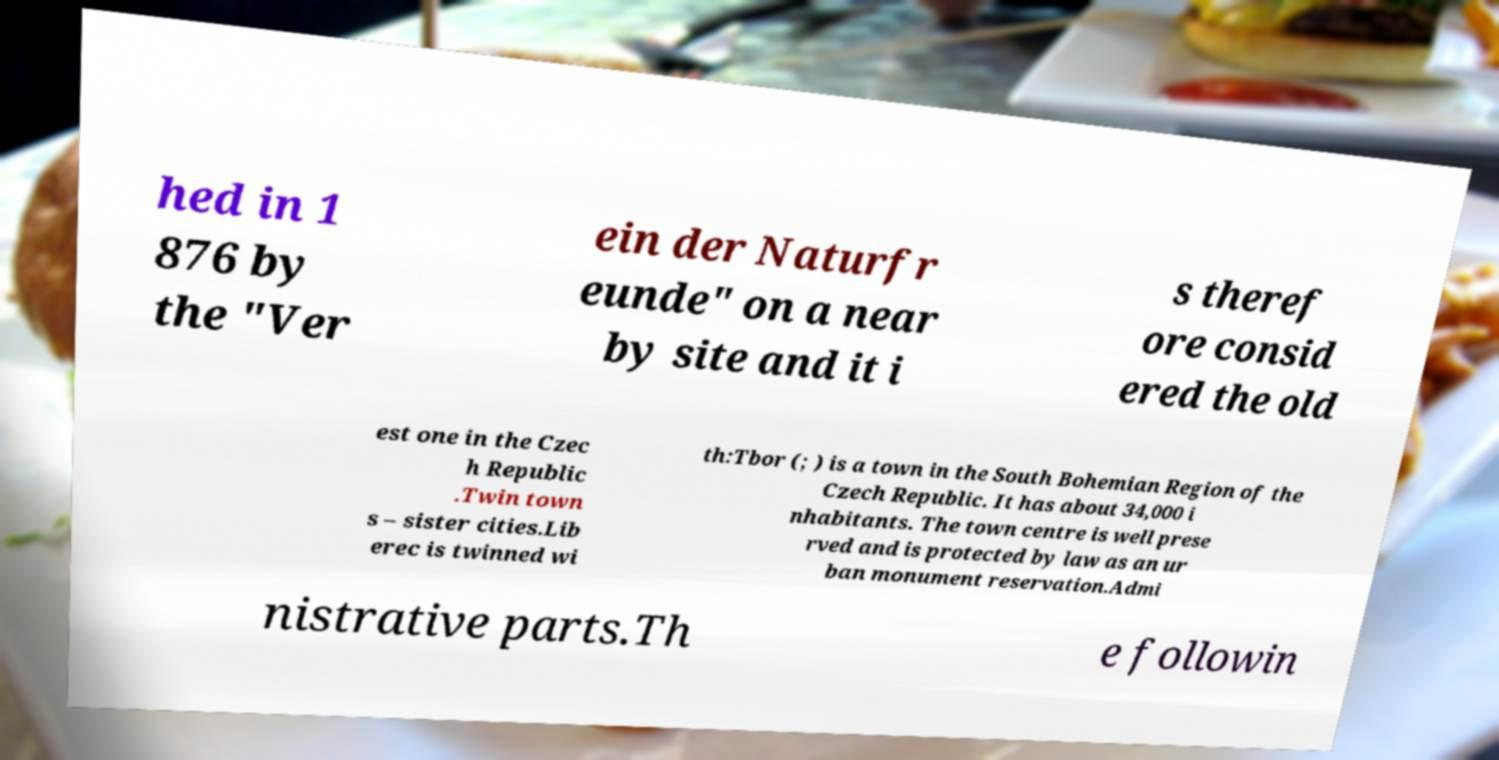What messages or text are displayed in this image? I need them in a readable, typed format. hed in 1 876 by the "Ver ein der Naturfr eunde" on a near by site and it i s theref ore consid ered the old est one in the Czec h Republic .Twin town s – sister cities.Lib erec is twinned wi th:Tbor (; ) is a town in the South Bohemian Region of the Czech Republic. It has about 34,000 i nhabitants. The town centre is well prese rved and is protected by law as an ur ban monument reservation.Admi nistrative parts.Th e followin 